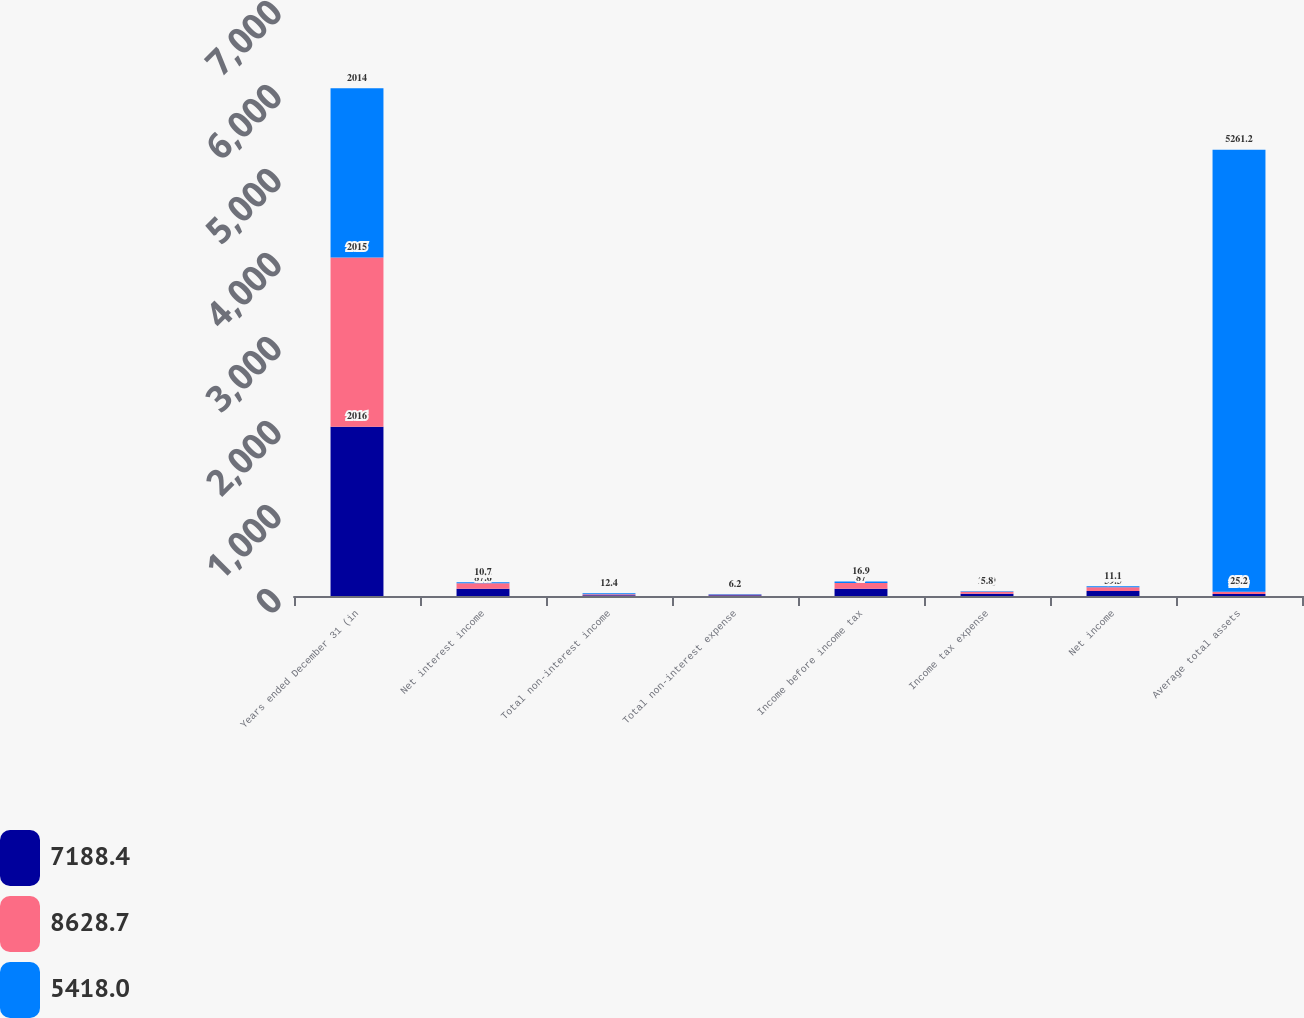Convert chart to OTSL. <chart><loc_0><loc_0><loc_500><loc_500><stacked_bar_chart><ecel><fcel>Years ended December 31 (in<fcel>Net interest income<fcel>Total non-interest income<fcel>Total non-interest expense<fcel>Income before income tax<fcel>Income tax expense<fcel>Net income<fcel>Average total assets<nl><fcel>7188.4<fcel>2016<fcel>87.6<fcel>9.2<fcel>9.8<fcel>87<fcel>27.5<fcel>59.5<fcel>25.2<nl><fcel>8628.7<fcel>2015<fcel>64.4<fcel>11.1<fcel>6.9<fcel>68.6<fcel>22.9<fcel>45.7<fcel>25.2<nl><fcel>5418<fcel>2014<fcel>10.7<fcel>12.4<fcel>6.2<fcel>16.9<fcel>5.8<fcel>11.1<fcel>5261.2<nl></chart> 